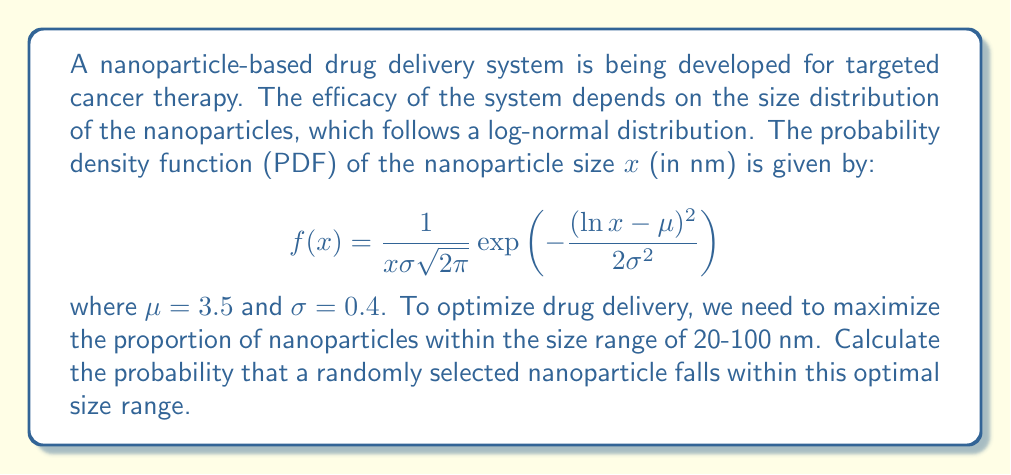What is the answer to this math problem? To solve this problem, we need to integrate the probability density function over the given range. Let's approach this step-by-step:

1) We need to find $P(20 \leq X \leq 100)$, where $X$ is the nanoparticle size.

2) This probability is given by the integral:

   $$P(20 \leq X \leq 100) = \int_{20}^{100} f(x) dx$$

3) Substituting the given PDF:

   $$P(20 \leq X \leq 100) = \int_{20}^{100} \frac{1}{x\sigma\sqrt{2\pi}} \exp\left(-\frac{(\ln x - \mu)^2}{2\sigma^2}\right) dx$$

4) This integral doesn't have a closed-form solution, so we need to use the standard normal cumulative distribution function $\Phi(z)$.

5) For a log-normal distribution, we can transform the problem into:

   $$P(20 \leq X \leq 100) = \Phi\left(\frac{\ln 100 - \mu}{\sigma}\right) - \Phi\left(\frac{\ln 20 - \mu}{\sigma}\right)$$

6) Substituting the given values $\mu = 3.5$ and $\sigma = 0.4$:

   $$P(20 \leq X \leq 100) = \Phi\left(\frac{\ln 100 - 3.5}{0.4}\right) - \Phi\left(\frac{\ln 20 - 3.5}{0.4}\right)$$

7) Simplifying:

   $$P(20 \leq X \leq 100) = \Phi(1.1478) - \Phi(-1.6094)$$

8) Using a standard normal distribution table or calculator:

   $$P(20 \leq X \leq 100) = 0.8745 - 0.0537 = 0.8208$$

Therefore, the probability that a randomly selected nanoparticle falls within the optimal size range is approximately 0.8208 or 82.08%.
Answer: 0.8208 